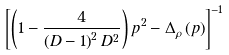Convert formula to latex. <formula><loc_0><loc_0><loc_500><loc_500>\left [ \left ( 1 - \frac { 4 } { { \left ( D - 1 \right ) ^ { 2 } D ^ { 2 } } } \right ) p ^ { 2 } - \Delta _ { \rho } \left ( p \right ) \right ] ^ { - 1 }</formula> 